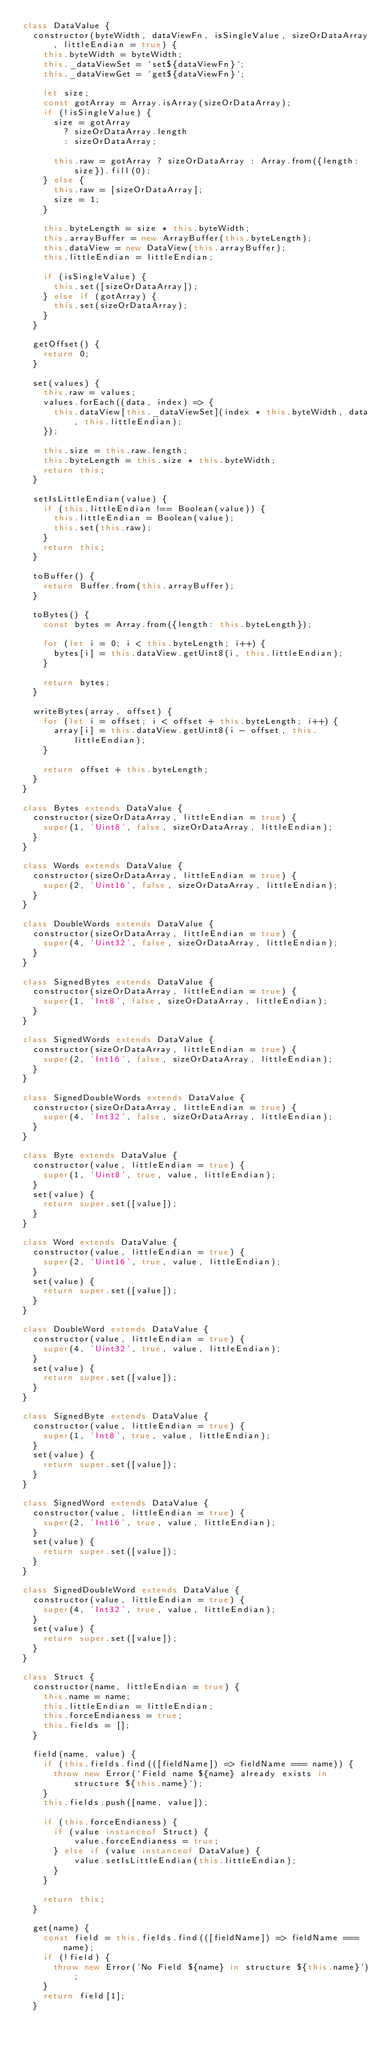<code> <loc_0><loc_0><loc_500><loc_500><_JavaScript_>class DataValue {
  constructor(byteWidth, dataViewFn, isSingleValue, sizeOrDataArray, littleEndian = true) {
    this.byteWidth = byteWidth;
    this._dataViewSet = `set${dataViewFn}`;
    this._dataViewGet = `get${dataViewFn}`;

    let size;
    const gotArray = Array.isArray(sizeOrDataArray);
    if (!isSingleValue) {
      size = gotArray
        ? sizeOrDataArray.length
        : sizeOrDataArray;

      this.raw = gotArray ? sizeOrDataArray : Array.from({length: size}).fill(0);
    } else {
      this.raw = [sizeOrDataArray];
      size = 1;
    }

    this.byteLength = size * this.byteWidth;
    this.arrayBuffer = new ArrayBuffer(this.byteLength);
    this.dataView = new DataView(this.arrayBuffer);
    this.littleEndian = littleEndian;

    if (isSingleValue) {
      this.set([sizeOrDataArray]);
    } else if (gotArray) {
      this.set(sizeOrDataArray);
    }
  }

  getOffset() {
    return 0;
  }

  set(values) {
    this.raw = values;
    values.forEach((data, index) => {
      this.dataView[this._dataViewSet](index * this.byteWidth, data, this.littleEndian);
    });

    this.size = this.raw.length;
    this.byteLength = this.size * this.byteWidth;
    return this;
  }

  setIsLittleEndian(value) {
    if (this.littleEndian !== Boolean(value)) {
      this.littleEndian = Boolean(value);
      this.set(this.raw);
    }
    return this;
  }

  toBuffer() {
    return Buffer.from(this.arrayBuffer);
  }

  toBytes() {
    const bytes = Array.from({length: this.byteLength});

    for (let i = 0; i < this.byteLength; i++) {
      bytes[i] = this.dataView.getUint8(i, this.littleEndian);
    }

    return bytes;
  }

  writeBytes(array, offset) {
    for (let i = offset; i < offset + this.byteLength; i++) {
      array[i] = this.dataView.getUint8(i - offset, this.littleEndian);
    }

    return offset + this.byteLength;
  }
}

class Bytes extends DataValue {
  constructor(sizeOrDataArray, littleEndian = true) {
    super(1, 'Uint8', false, sizeOrDataArray, littleEndian);
  }
}

class Words extends DataValue {
  constructor(sizeOrDataArray, littleEndian = true) {
    super(2, 'Uint16', false, sizeOrDataArray, littleEndian);
  }
}

class DoubleWords extends DataValue {
  constructor(sizeOrDataArray, littleEndian = true) {
    super(4, 'Uint32', false, sizeOrDataArray, littleEndian);
  }
}

class SignedBytes extends DataValue {
  constructor(sizeOrDataArray, littleEndian = true) {
    super(1, 'Int8', false, sizeOrDataArray, littleEndian);
  }
}

class SignedWords extends DataValue {
  constructor(sizeOrDataArray, littleEndian = true) {
    super(2, 'Int16', false, sizeOrDataArray, littleEndian);
  }
}

class SignedDoubleWords extends DataValue {
  constructor(sizeOrDataArray, littleEndian = true) {
    super(4, 'Int32', false, sizeOrDataArray, littleEndian);
  }
}

class Byte extends DataValue {
  constructor(value, littleEndian = true) {
    super(1, 'Uint8', true, value, littleEndian);
  }
  set(value) {
    return super.set([value]);
  }
}

class Word extends DataValue {
  constructor(value, littleEndian = true) {
    super(2, 'Uint16', true, value, littleEndian);
  }
  set(value) {
    return super.set([value]);
  }
}

class DoubleWord extends DataValue {
  constructor(value, littleEndian = true) {
    super(4, 'Uint32', true, value, littleEndian);
  }
  set(value) {
    return super.set([value]);
  }
}

class SignedByte extends DataValue {
  constructor(value, littleEndian = true) {
    super(1, 'Int8', true, value, littleEndian);
  }
  set(value) {
    return super.set([value]);
  }
}

class SignedWord extends DataValue {
  constructor(value, littleEndian = true) {
    super(2, 'Int16', true, value, littleEndian);
  }
  set(value) {
    return super.set([value]);
  }
}

class SignedDoubleWord extends DataValue {
  constructor(value, littleEndian = true) {
    super(4, 'Int32', true, value, littleEndian);
  }
  set(value) {
    return super.set([value]);
  }
}

class Struct {
  constructor(name, littleEndian = true) {
    this.name = name;
    this.littleEndian = littleEndian;
    this.forceEndianess = true;
    this.fields = [];
  }

  field(name, value) {
    if (this.fields.find(([fieldName]) => fieldName === name)) {
      throw new Error(`Field name ${name} already exists in structure ${this.name}`);
    }
    this.fields.push([name, value]);

    if (this.forceEndianess) {
      if (value instanceof Struct) {
          value.forceEndianess = true;
      } else if (value instanceof DataValue) {
          value.setIsLittleEndian(this.littleEndian);
      }
    }

    return this;
  }

  get(name) {
    const field = this.fields.find(([fieldName]) => fieldName === name);
    if (!field) {
      throw new Error(`No Field ${name} in structure ${this.name}`);
    }
    return field[1];
  }
</code> 